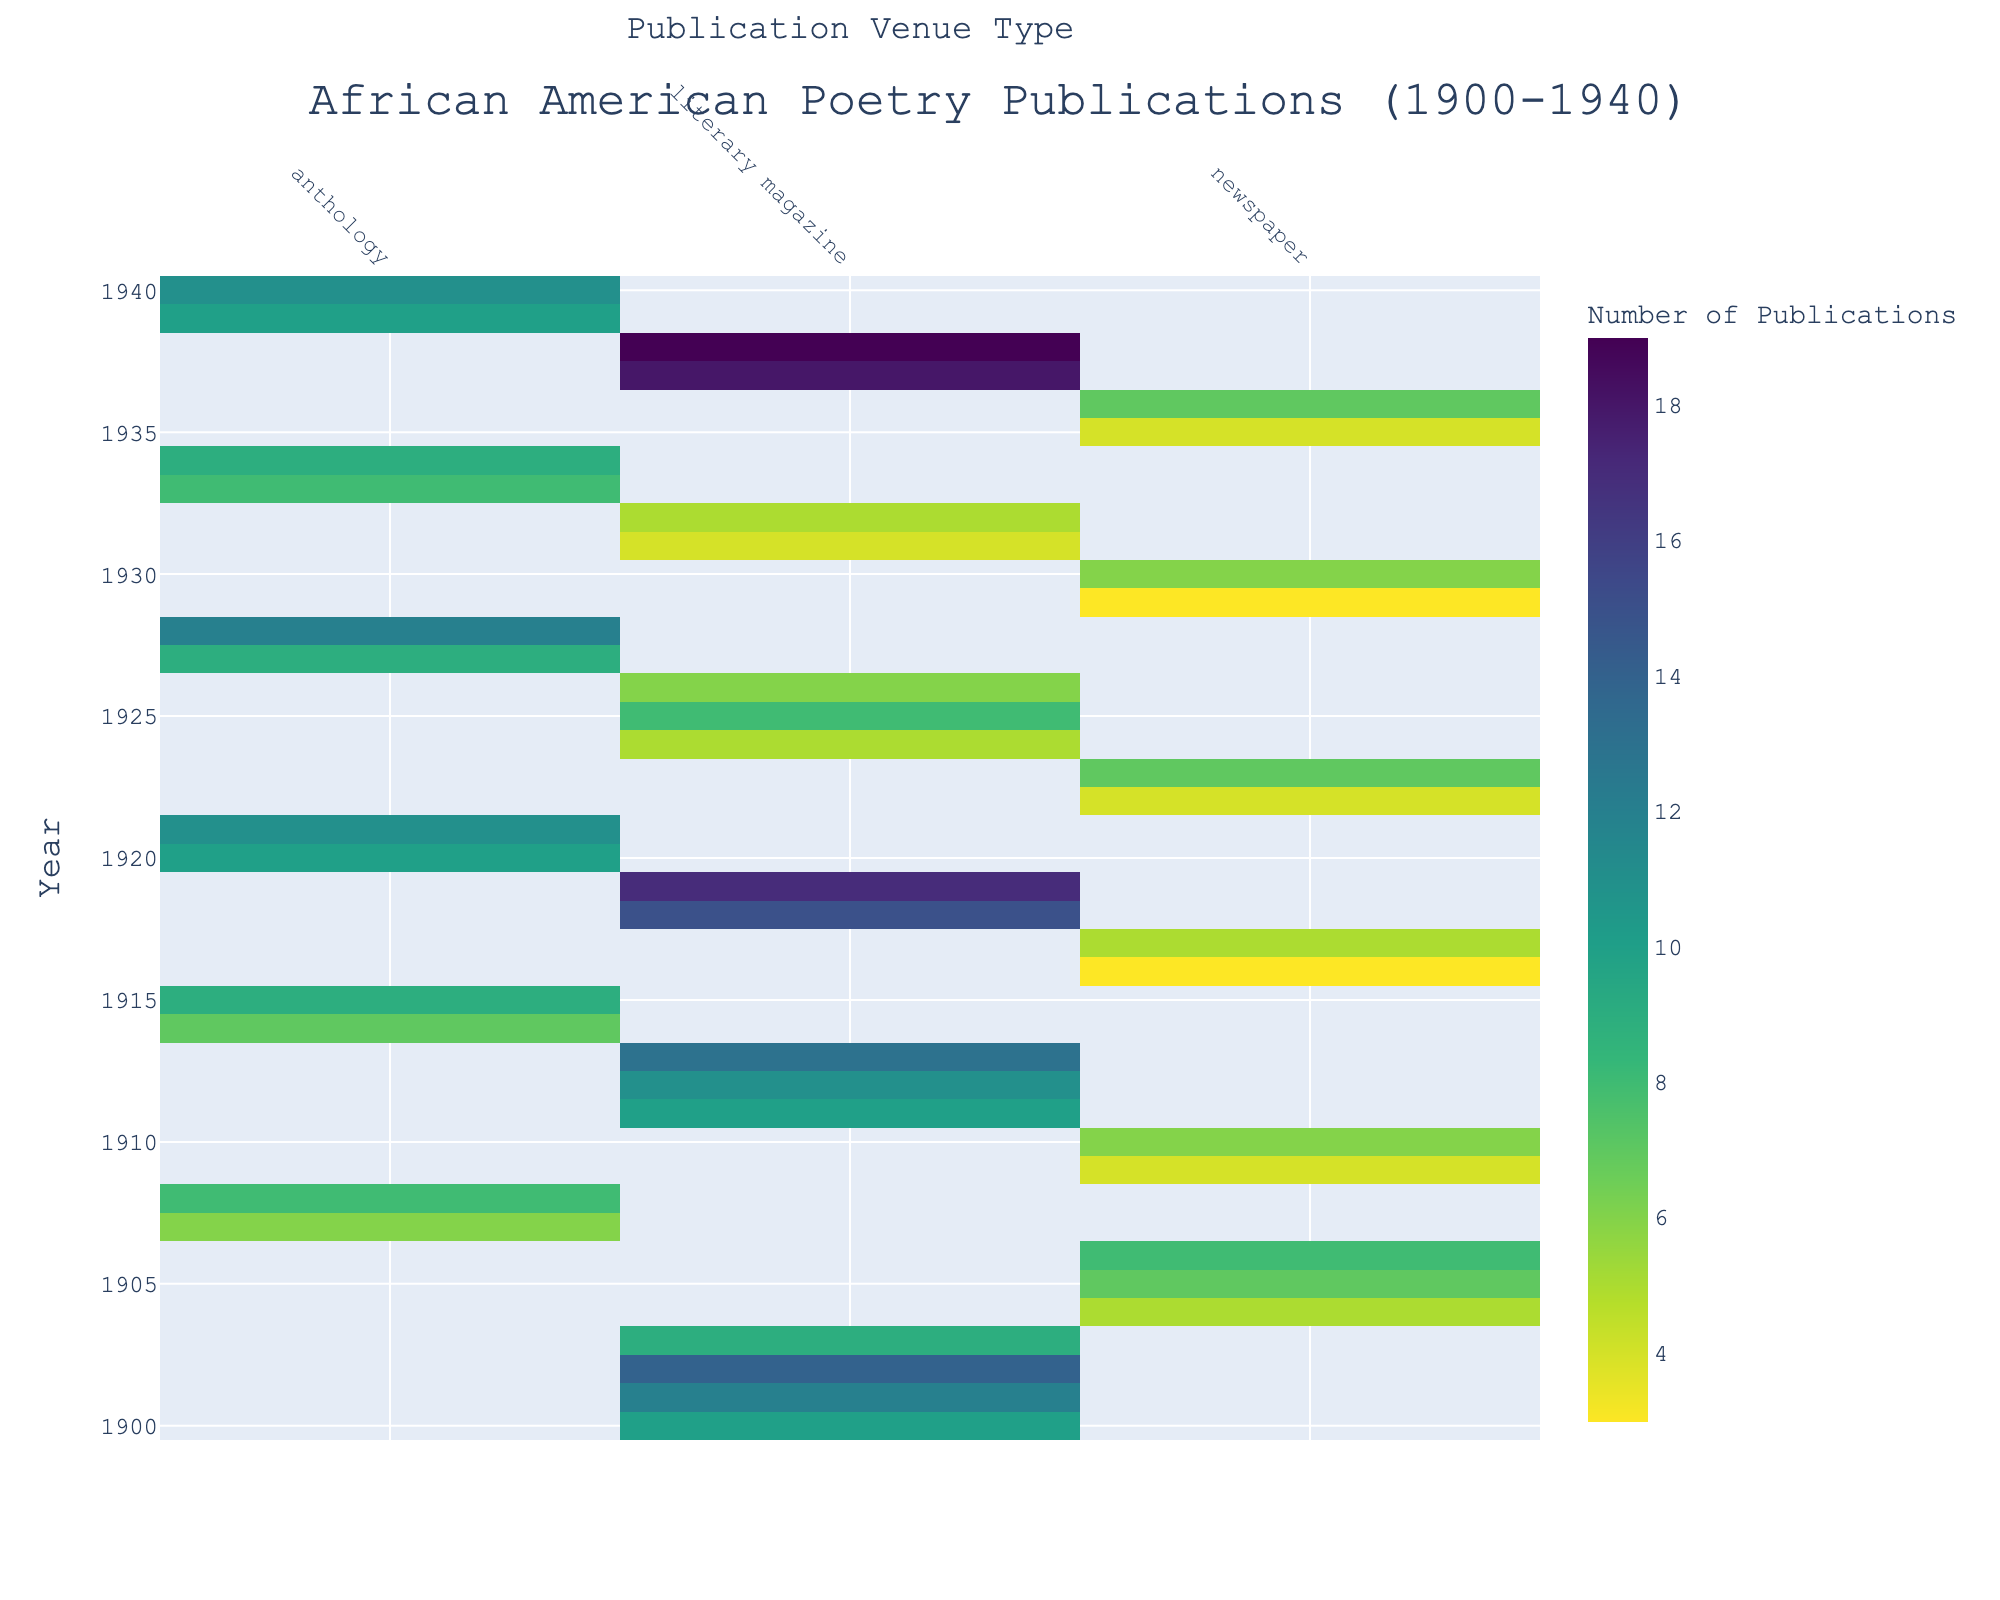what is the title of the heatmap? The title of the heatmap is the text displayed prominently at the top of the figure. It provides an overview of what the plot is about, which in this case is "African American Poetry Publications (1900-1940)".
Answer: African American Poetry Publications (1900-1940) Which year has the highest number of publications in literary magazines? To find the year with the highest number of publications in literary magazines, look for the maximum value along the 'literary magazine' column in the heatmap and identify the corresponding year. In this heatmap, the year 1938 has the highest number of publications with 19.
Answer: 1938 How many publications were made in newspapers in 1922? To determine the number of publications in newspapers for the year 1922, locate the cell where the 'newspaper' column intersects with the row '1922'. The value in this cell indicates how many publications were made, which is 4.
Answer: 4 Which venue type had more publications in 1913: literary magazines or anthologies? Compare the values of 'literary magazines' and 'anthologies' for the year 1913. In 1913, the 'literary magazine' has 13 publications, while there were no publications listed for 'anthologies'. Therefore, literary magazines had more publications.
Answer: Literary magazines What is the total number of publications in anthologies between 1920 and 1930? Sum the number of publications in the 'anthology' column for the years between 1920 and 1930. These values are 10, 11, 9, and 12. Adding these gives: 10+11+9+12 = 42.
Answer: 42 Did The Crisis have more publications in 1907 or in 1937? The number of publications for 'The Crisis' in each year is not given directly and must be inferred from the venue type 'literary magazine' and its occurrences in relevant years. For 1907, The Crisis had no publications listed. In 1937, The Crisis had 18 publications. Hence, The Crisis had more publications in 1937.
Answer: 1937 What is the general trend in the number of literary magazine publications from 1900 to 1940? To observe the general trend, look at the values in the literary magazine column from 1900 to 1940. Initially, the values fluctuate but there is an overall increasing trend with some high peaks in later years, culminating in the highest values around the late 1930s.
Answer: Increasing How many venues are represented in the heatmap? Observe the unique column names representing the different venue types in the heatmap. These include literary magazines, anthologies, and newspapers. Count these columns.
Answer: 3 Which venue type shows the most consistent number of publications over time? To determine the most consistent number of publications, observe the heatmap columns and note which type shows relatively stable values across different years. The 'newspaper' column shows a relatively steady range of numbers with fewer extreme fluctuations compared to other venue types.
Answer: Newspapers 